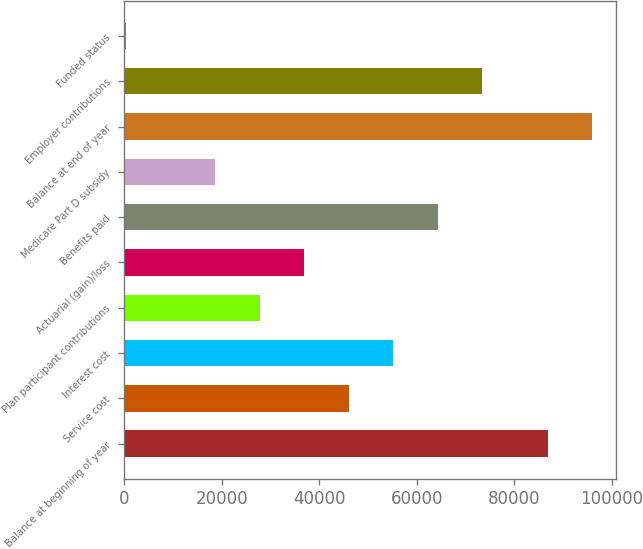Convert chart. <chart><loc_0><loc_0><loc_500><loc_500><bar_chart><fcel>Balance at beginning of year<fcel>Service cost<fcel>Interest cost<fcel>Plan participant contributions<fcel>Actuarial (gain)/loss<fcel>Benefits paid<fcel>Medicare Part D subsidy<fcel>Balance at end of year<fcel>Employer contributions<fcel>Funded status<nl><fcel>86844<fcel>46012<fcel>55130.2<fcel>27775.6<fcel>36893.8<fcel>64248.4<fcel>18657.4<fcel>95962.2<fcel>73366.6<fcel>421<nl></chart> 